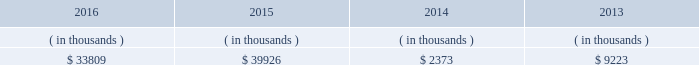System energy resources , inc .
Management 2019s financial discussion and analysis also in addition to the contractual obligations , system energy has $ 382.3 million of unrecognized tax benefits and interest net of unused tax attributes and payments for which the timing of payments beyond 12 months cannot be reasonably estimated due to uncertainties in the timing of effective settlement of tax positions .
See note 3 to the financial statements for additional information regarding unrecognized tax benefits .
In addition to routine spending to maintain operations , the planned capital investment estimate includes specific investments and initiatives such as the nuclear fleet operational excellence initiative , as discussed below in 201cnuclear matters , 201d and plant improvements .
As a wholly-owned subsidiary , system energy dividends its earnings to entergy corporation at a percentage determined monthly .
Sources of capital system energy 2019s sources to meet its capital requirements include : 2022 internally generated funds ; 2022 cash on hand ; 2022 debt issuances ; and 2022 bank financing under new or existing facilities .
System energy may refinance , redeem , or otherwise retire debt prior to maturity , to the extent market conditions and interest and dividend rates are favorable .
All debt and common stock issuances by system energy require prior regulatory approval .
Debt issuances are also subject to issuance tests set forth in its bond indentures and other agreements .
System energy has sufficient capacity under these tests to meet its foreseeable capital needs .
System energy 2019s receivables from the money pool were as follows as of december 31 for each of the following years. .
See note 4 to the financial statements for a description of the money pool .
The system energy nuclear fuel company variable interest entity has a credit facility in the amount of $ 120 million scheduled to expire in may 2019 .
As of december 31 , 2016 , $ 66.9 million in letters of credit were outstanding under the credit facility to support a like amount of commercial paper issued by the system energy nuclear fuel company variable interest entity .
See note 4 to the financial statements for additional discussion of the variable interest entity credit facility .
System energy obtained authorizations from the ferc through october 2017 for the following : 2022 short-term borrowings not to exceed an aggregate amount of $ 200 million at any time outstanding ; 2022 long-term borrowings and security issuances ; and 2022 long-term borrowings by its nuclear fuel company variable interest entity .
See note 4 to the financial statements for further discussion of system energy 2019s short-term borrowing limits. .
For the period from 2013 to 2016 , what was the combined balance ( in thousands ) for money pool receivables?\\n? 
Computations: (((33809 + 39926) + 2373) + 9223)
Answer: 85331.0. 